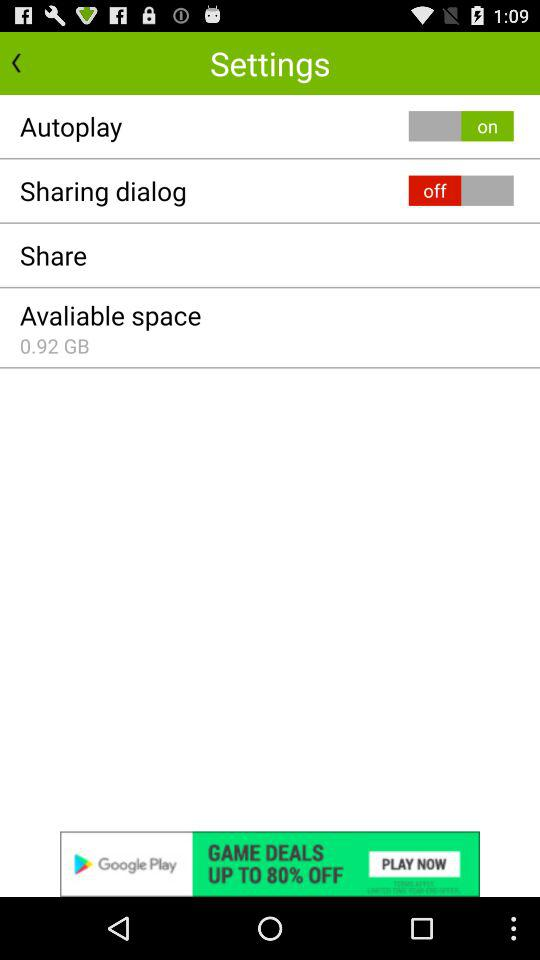How much space is available? The available space is 0.92 GB. 